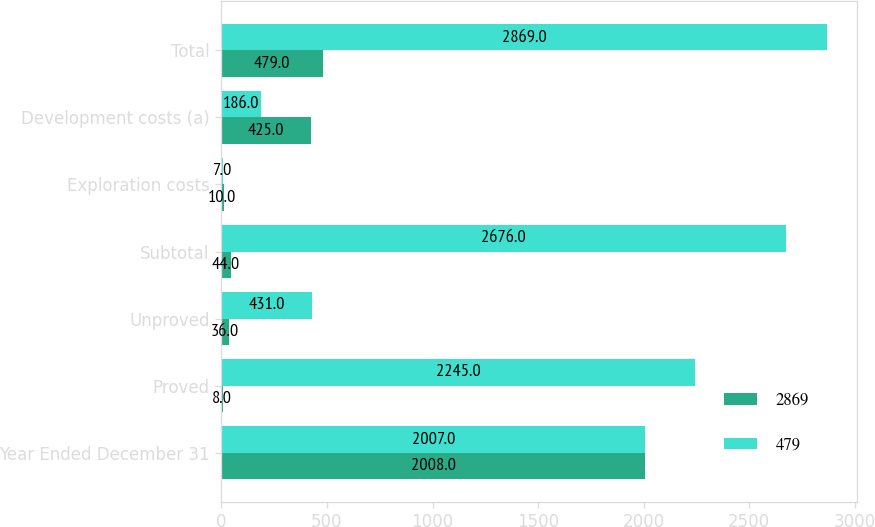<chart> <loc_0><loc_0><loc_500><loc_500><stacked_bar_chart><ecel><fcel>Year Ended December 31<fcel>Proved<fcel>Unproved<fcel>Subtotal<fcel>Exploration costs<fcel>Development costs (a)<fcel>Total<nl><fcel>2869<fcel>2008<fcel>8<fcel>36<fcel>44<fcel>10<fcel>425<fcel>479<nl><fcel>479<fcel>2007<fcel>2245<fcel>431<fcel>2676<fcel>7<fcel>186<fcel>2869<nl></chart> 